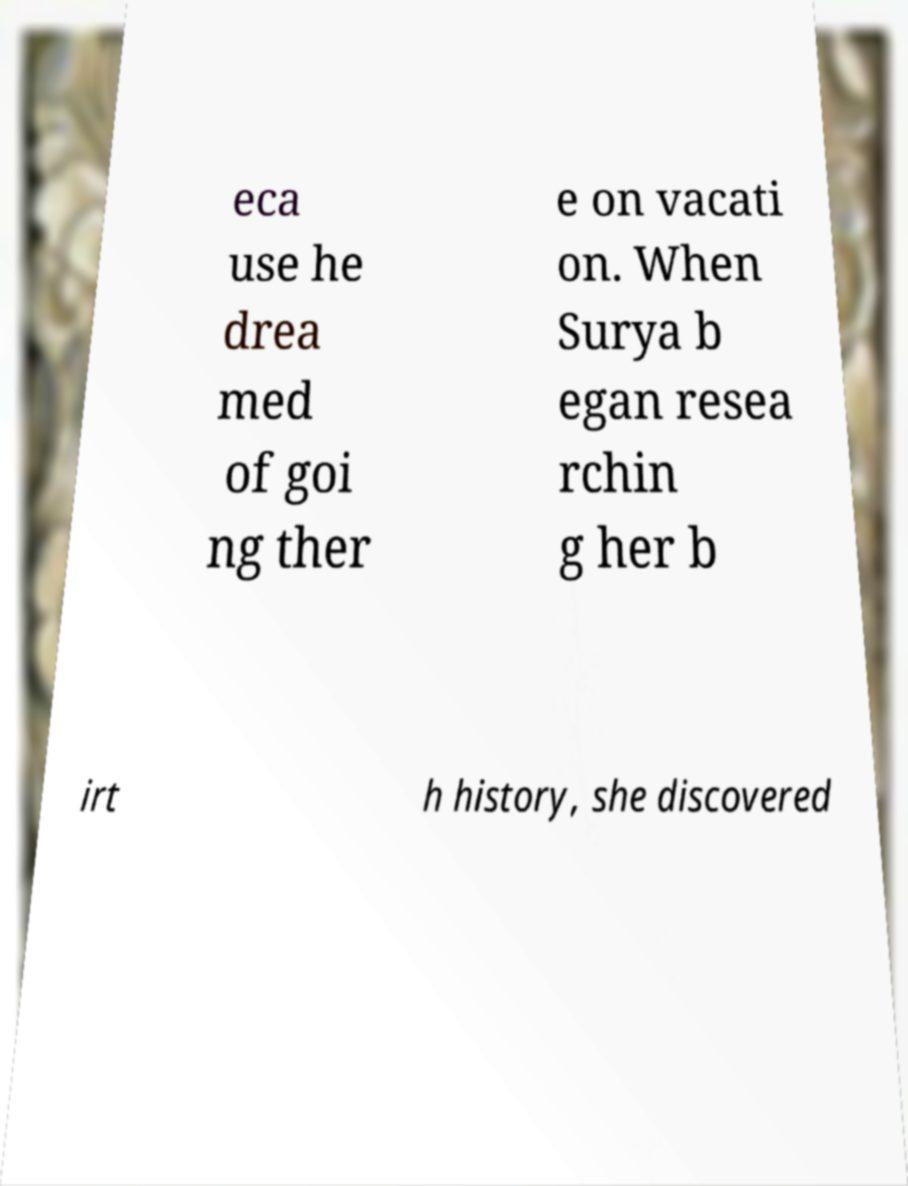Could you assist in decoding the text presented in this image and type it out clearly? eca use he drea med of goi ng ther e on vacati on. When Surya b egan resea rchin g her b irt h history, she discovered 